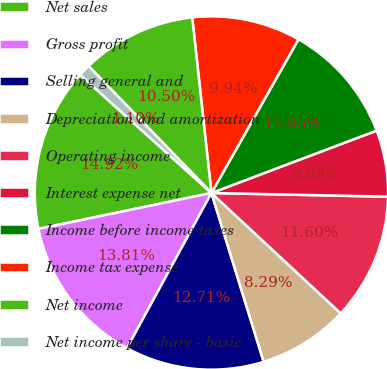<chart> <loc_0><loc_0><loc_500><loc_500><pie_chart><fcel>Net sales<fcel>Gross profit<fcel>Selling general and<fcel>Depreciation and amortization<fcel>Operating income<fcel>Interest expense net<fcel>Income before income taxes<fcel>Income tax expense<fcel>Net income<fcel>Net income per share - basic<nl><fcel>14.92%<fcel>13.81%<fcel>12.71%<fcel>8.29%<fcel>11.6%<fcel>6.08%<fcel>11.05%<fcel>9.94%<fcel>10.5%<fcel>1.1%<nl></chart> 